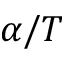Convert formula to latex. <formula><loc_0><loc_0><loc_500><loc_500>\alpha / T</formula> 